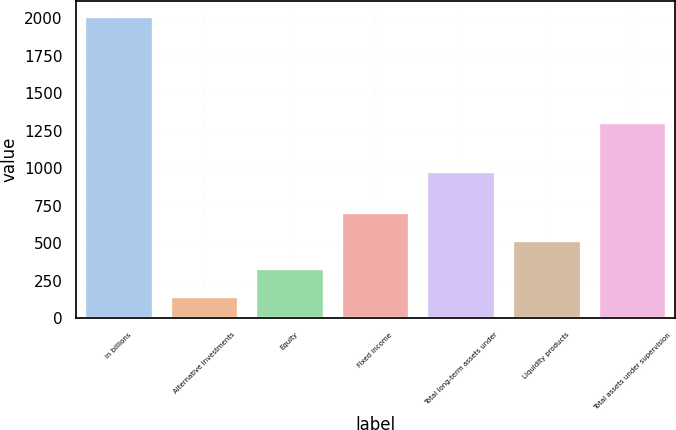<chart> <loc_0><loc_0><loc_500><loc_500><bar_chart><fcel>in billions<fcel>Alternative investments<fcel>Equity<fcel>Fixed income<fcel>Total long-term assets under<fcel>Liquidity products<fcel>Total assets under supervision<nl><fcel>2016<fcel>149<fcel>335.7<fcel>709.1<fcel>983<fcel>522.4<fcel>1309<nl></chart> 